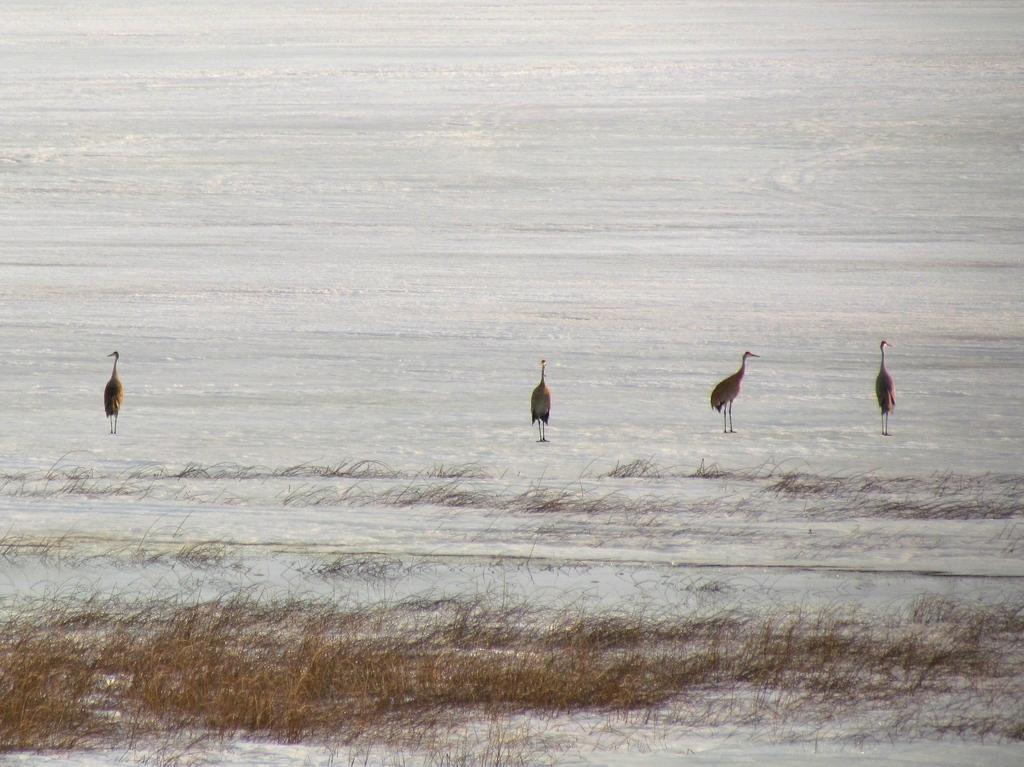Can you describe this image briefly? In this image I can see ground full of snow and on it I can see four birds are standing. On the bottom side of the image I can see grass on the ground. 